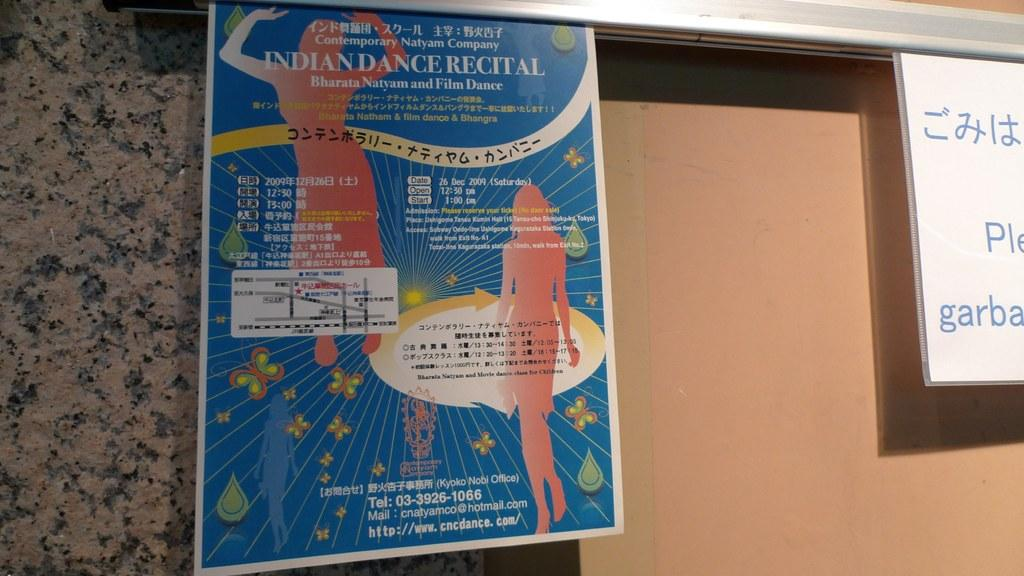Provide a one-sentence caption for the provided image. A large blue poster contains a lot of information about an Indian Dance Recital. 